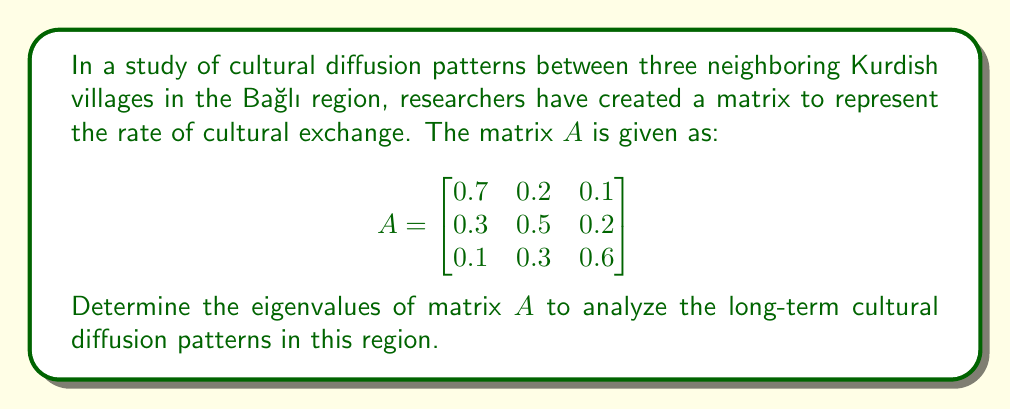What is the answer to this math problem? To find the eigenvalues of matrix $A$, we need to solve the characteristic equation:

$\det(A - \lambda I) = 0$

Where $I$ is the $3 \times 3$ identity matrix and $\lambda$ represents the eigenvalues.

Step 1: Set up the characteristic equation
$$\det\begin{pmatrix}
0.7 - \lambda & 0.2 & 0.1 \\
0.3 & 0.5 - \lambda & 0.2 \\
0.1 & 0.3 & 0.6 - \lambda
\end{pmatrix} = 0$$

Step 2: Expand the determinant
$$(0.7 - \lambda)[(0.5 - \lambda)(0.6 - \lambda) - 0.06] - 0.2[0.3(0.6 - \lambda) - 0.02] + 0.1[0.3(0.5 - \lambda) - 0.06] = 0$$

Step 3: Simplify
$$(0.7 - \lambda)(0.3 - 1.1\lambda + \lambda^2) - 0.2(0.18 - 0.3\lambda) + 0.1(0.15 - 0.3\lambda) = 0$$

$$(0.21 - 0.77\lambda + 0.7\lambda^2 - 0.3\lambda + 1.1\lambda^2 - \lambda^3) - (0.036 - 0.06\lambda) + (0.015 - 0.03\lambda) = 0$$

Step 4: Collect terms
$$-\lambda^3 + 1.8\lambda^2 - 1.07\lambda + 0.189 = 0$$

Step 5: Solve the cubic equation
This cubic equation can be solved using various methods, such as the cubic formula or numerical methods. The exact solutions are:

$\lambda_1 = 1$
$\lambda_2 = 0.5$
$\lambda_3 = 0.3$

These eigenvalues represent the principal components of cultural diffusion in the system.
Answer: The eigenvalues of matrix $A$ are: $\lambda_1 = 1$, $\lambda_2 = 0.5$, and $\lambda_3 = 0.3$. 